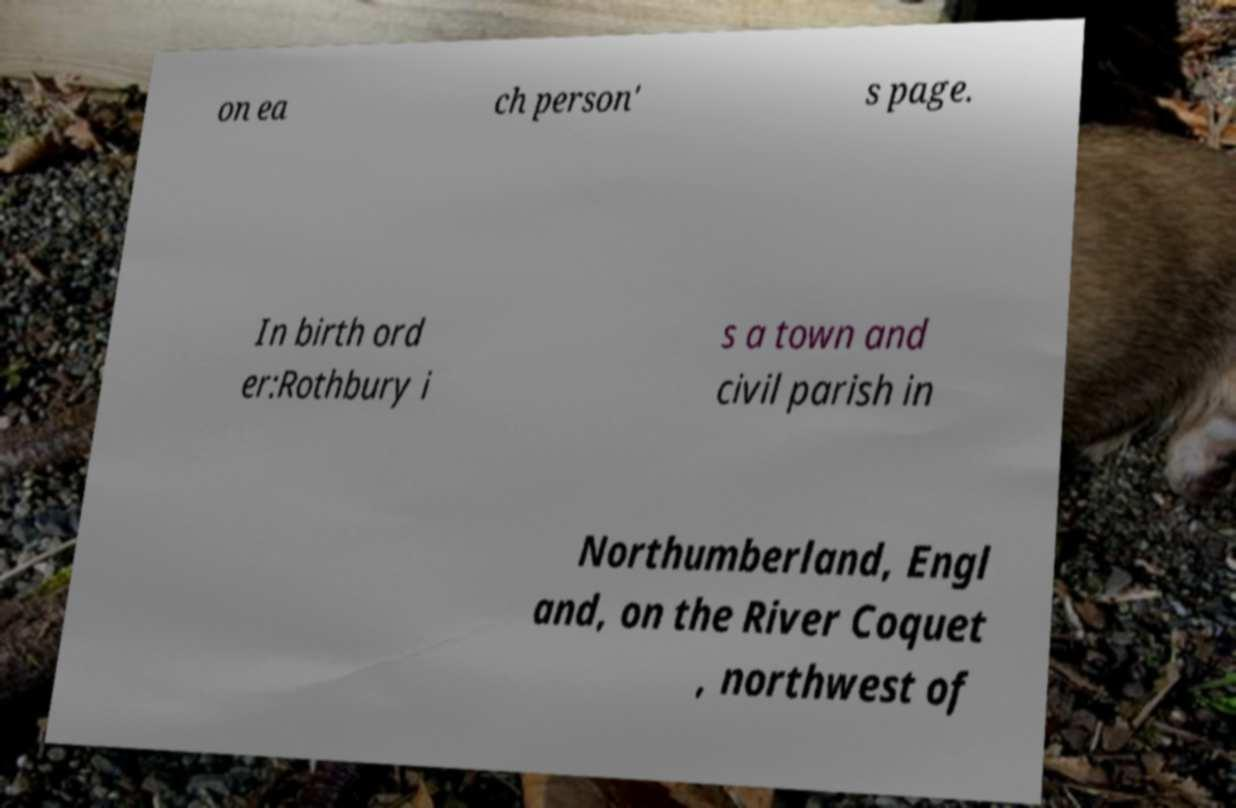Please read and relay the text visible in this image. What does it say? on ea ch person' s page. In birth ord er:Rothbury i s a town and civil parish in Northumberland, Engl and, on the River Coquet , northwest of 